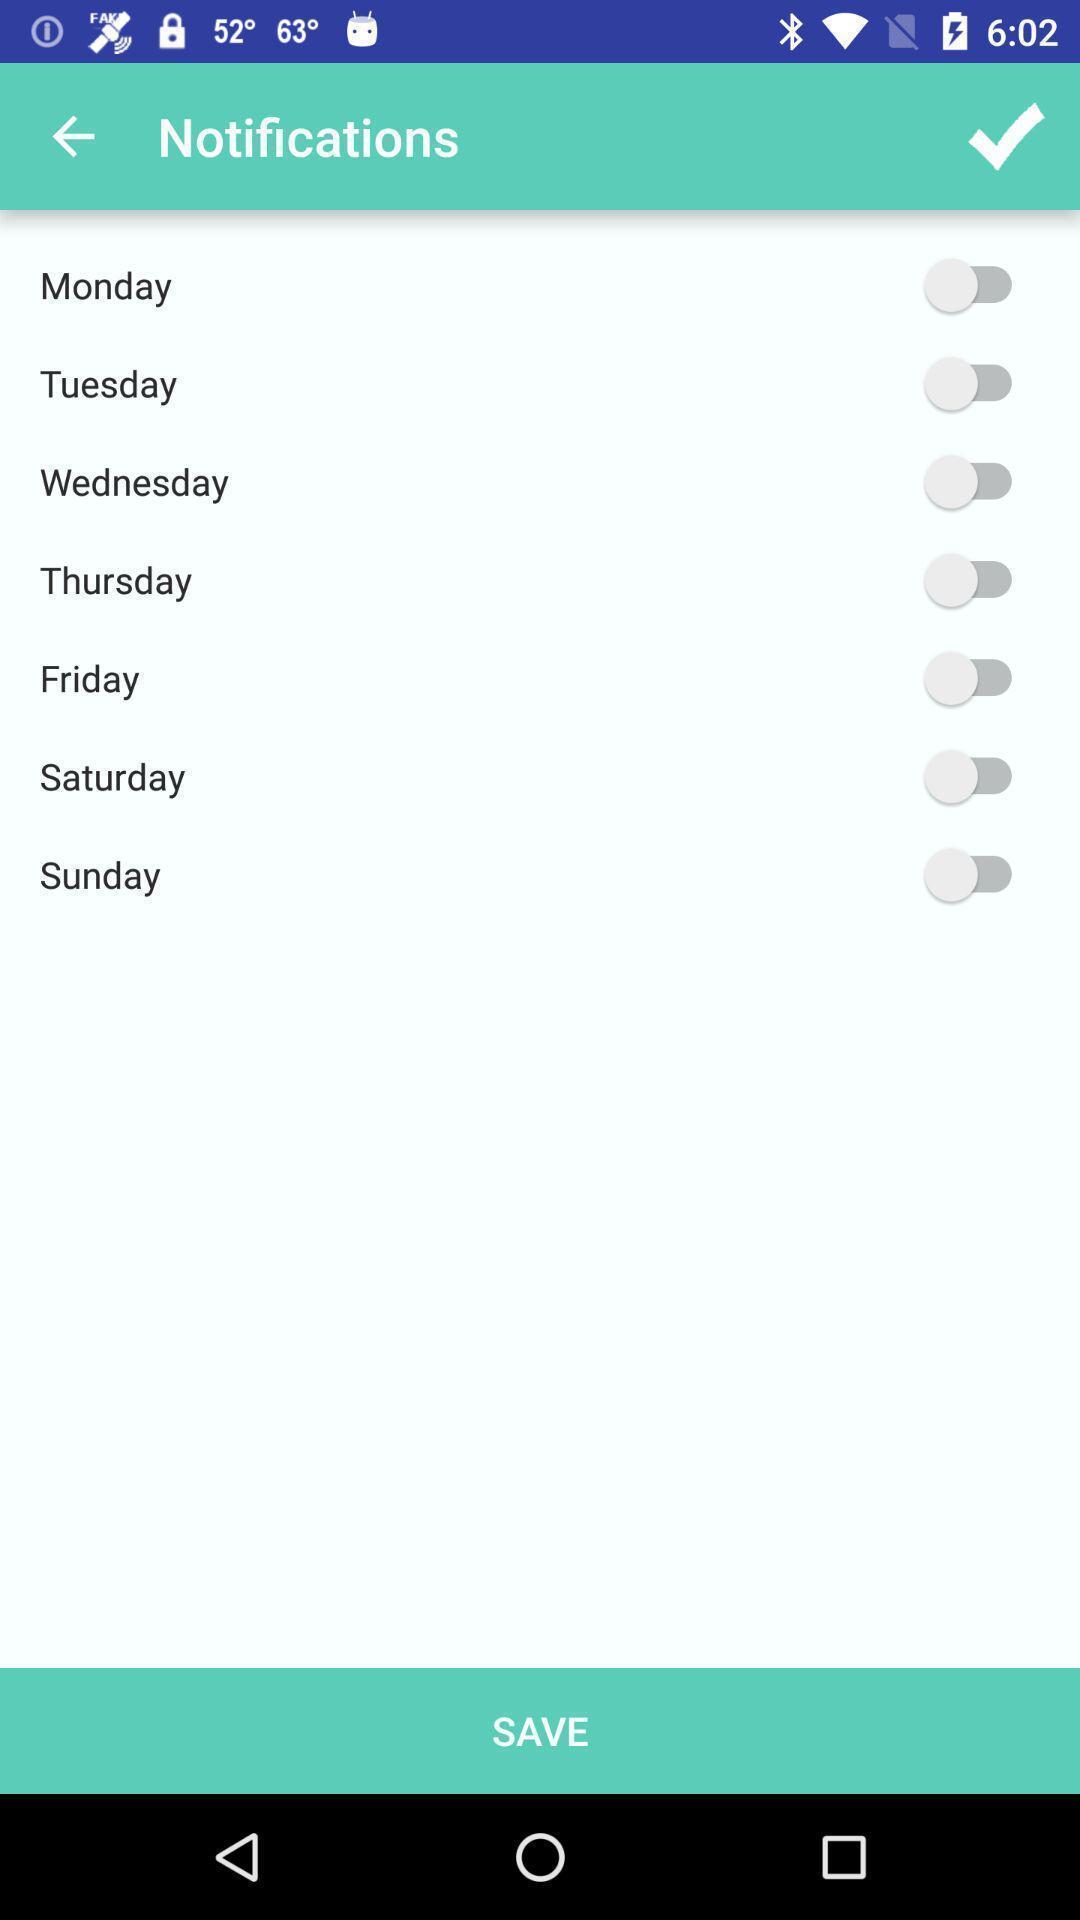Describe this image in words. Screen shows notifications. 